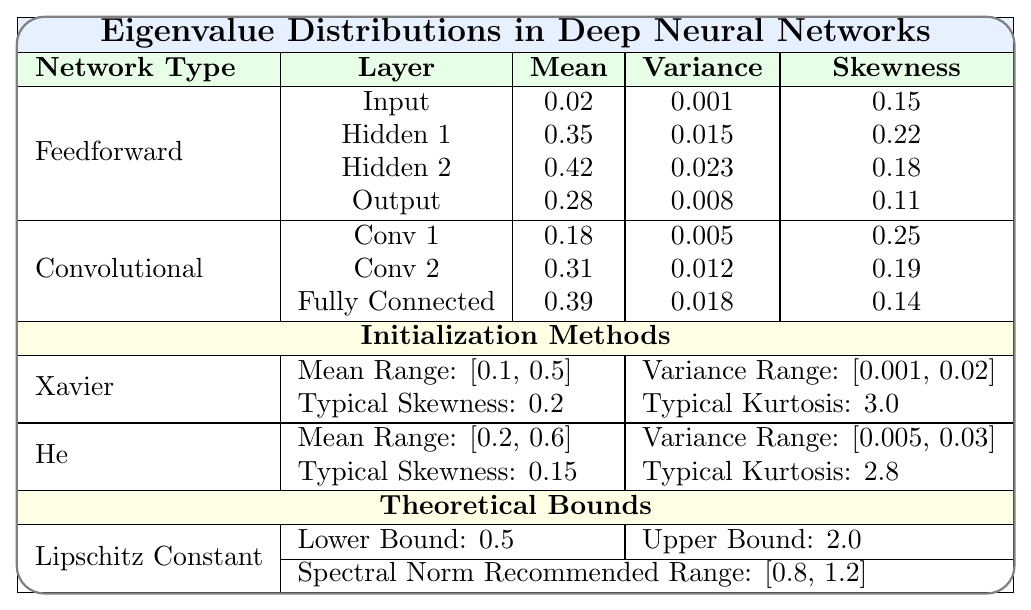What is the Mean eigenvalue for the Output layer in the Feedforward network? From the table, the Mean eigenvalue for the Output layer under the Feedforward network type is indicated as 0.28.
Answer: 0.28 Which layer in the Convolutional network has the highest Variance in eigenvalue distribution? By examining the Variance values, Conv 2 has a Variance of 0.012, which is higher than Conv 1 (0.005) and Fully Connected (0.018). Therefore, Fully Connected has the highest Variance.
Answer: Fully Connected What is the difference in Skewness between Hidden 2 and the Output layer in the Feedforward network? The Skewness for Hidden 2 is 0.18 and for the Output layer is 0.11. Thus, the difference is calculated as 0.18 - 0.11 = 0.07.
Answer: 0.07 Is the Mean eigenvalue of Conv 1 greater than that of the Input layer in the Feedforward network? The Mean eigenvalue for Conv 1 is 0.18, while for the Input layer it is 0.02. Since 0.18 is greater than 0.02, the answer is yes.
Answer: Yes What is the average Mean eigenvalue across all layers in the Feedforward network? The Mean eigenvalues for Feedforward layers are 0.02, 0.35, 0.42, and 0.28. Summing these gives 0.02 + 0.35 + 0.42 + 0.28 = 1.07. Dividing by the number of layers (4) gives an average of 1.07/4 = 0.2675.
Answer: 0.2675 Which Initialization Method has a lower Typical Skewness, Xavier or He? The Typical Skewness for Xavier is 0.2 and for He it is 0.15. Since 0.15 is lower than 0.2, He has the lower Typical Skewness.
Answer: He What is the combined Mean eigenvalue of all layers in the Convolutional network? The Mean eigenvalues for the Convolutional layers are 0.18, 0.31, and 0.39. Adding them results in 0.18 + 0.31 + 0.39 = 0.88.
Answer: 0.88 Is the Variance for any layer in the Convolutional network equal to 0.02? Checking the Variance values for the Convolutional layers, we see they are 0.005, 0.012, and 0.018 respectively, none of which equal 0.02. Therefore, the answer is no.
Answer: No What is the relationship between the Mean Range of the Xavier initialization and the eigenvalue Mean of Hidden 1 in the Feedforward network? The Mean Range for Xavier initialization is [0.1, 0.5] and the Mean for Hidden 1 is 0.35, which falls within the given range of 0.1 to 0.5. Thus, it corresponds to the defined range.
Answer: It falls within the range What is the difference in Kurtosis between the Conv 1 layer and the Hidden 1 layer? The Kurtosis for Conv 1 is 3.4 and for Hidden 1 it is 3.1, thus the difference is 3.4 - 3.1 = 0.3.
Answer: 0.3 How do the recommended Spectral Norm bounds compare to the Mean eigenvalue of the Output layer? The Spectral Norm Recommended Range is [0.8, 1.2], and the Mean eigenvalue for the Output layer is 0.28, which is outside the recommended bounds. Thus, it is lower than the lower bound.
Answer: It is lower than the lower bound 